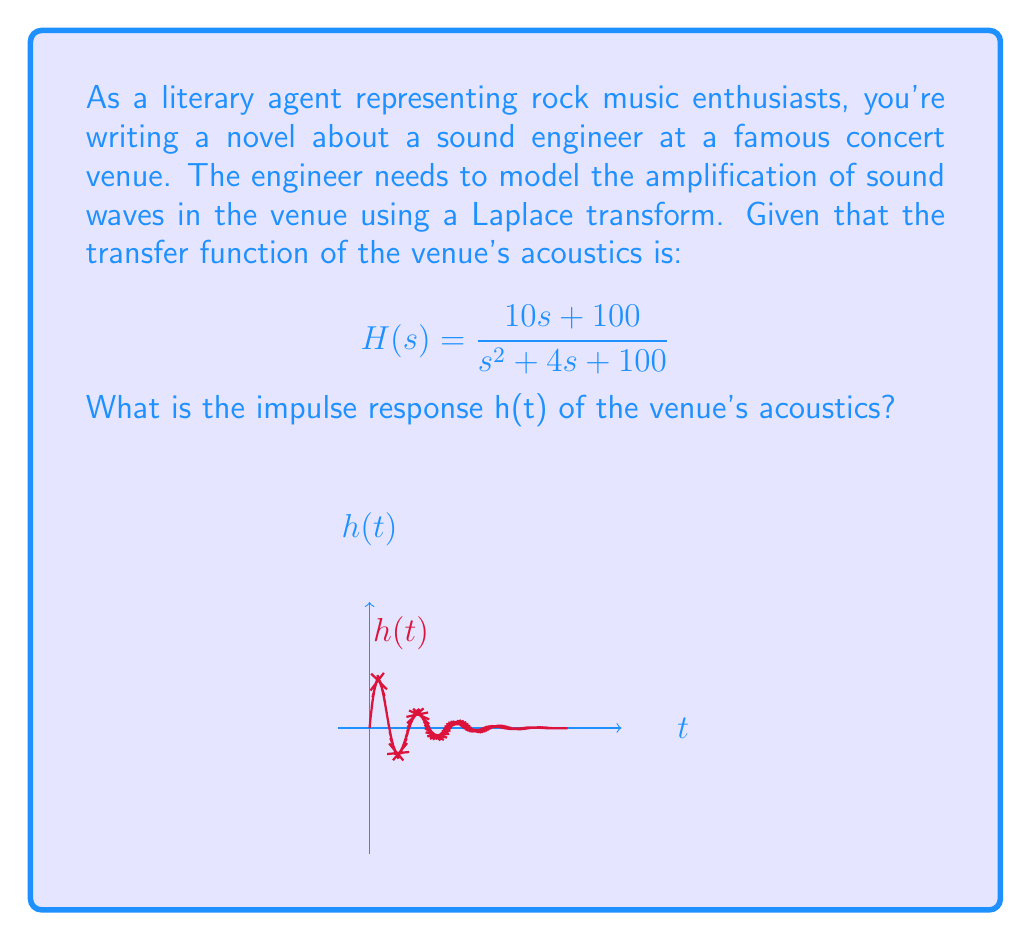Help me with this question. To find the impulse response h(t), we need to take the inverse Laplace transform of H(s). Let's approach this step-by-step:

1) First, let's rewrite H(s) in a standard form:
   $$H(s) = \frac{10s + 100}{s^2 + 4s + 100} = 10 \cdot \frac{s + 10}{s^2 + 4s + 100}$$

2) The denominator can be factored as:
   $$s^2 + 4s + 100 = (s+2)^2 + 96 = (s+2)^2 + (\sqrt{96})^2$$

3) This is in the form of $(s+a)^2 + b^2$, which corresponds to the Laplace transform of $e^{-at}\sin(bt)$.

4) Therefore, we can write:
   $$H(s) = 10 \cdot \frac{s + 10}{(s+2)^2 + 10^2}$$

5) The inverse Laplace transform of this form is:
   $$\mathcal{L}^{-1}\left\{\frac{s + a}{(s+b)^2 + \omega^2}\right\} = e^{-bt}\left(\cos(\omega t) + \frac{a-b}{\omega}\sin(\omega t)\right)$$

6) In our case, $a=10$, $b=2$, and $\omega=10$.

7) Applying this to our H(s):
   $$h(t) = 10 \cdot e^{-2t}\left(\cos(10t) + \frac{10-2}{10}\sin(10t)\right)$$

8) Simplifying:
   $$h(t) = 10e^{-2t}(\cos(10t) + 0.8\sin(10t))$$

9) This can be further simplified to:
   $$h(t) = 10e^{-2t}\sin(10t)$$

This function represents the impulse response of the venue's acoustics.
Answer: $h(t) = 10e^{-2t}\sin(10t)$ 